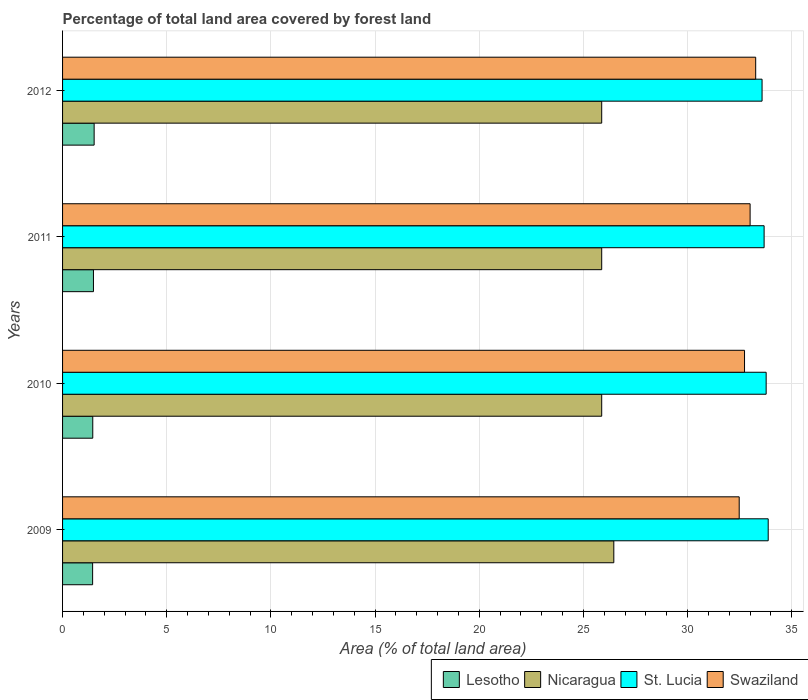Are the number of bars on each tick of the Y-axis equal?
Keep it short and to the point. Yes. How many bars are there on the 4th tick from the top?
Your response must be concise. 4. How many bars are there on the 1st tick from the bottom?
Offer a very short reply. 4. What is the label of the 4th group of bars from the top?
Make the answer very short. 2009. What is the percentage of forest land in Swaziland in 2011?
Make the answer very short. 33. Across all years, what is the maximum percentage of forest land in Nicaragua?
Provide a short and direct response. 26.46. Across all years, what is the minimum percentage of forest land in Nicaragua?
Keep it short and to the point. 25.88. In which year was the percentage of forest land in Lesotho maximum?
Offer a very short reply. 2012. In which year was the percentage of forest land in Lesotho minimum?
Offer a very short reply. 2009. What is the total percentage of forest land in Nicaragua in the graph?
Your answer should be compact. 104.09. What is the difference between the percentage of forest land in St. Lucia in 2011 and that in 2012?
Your response must be concise. 0.1. What is the difference between the percentage of forest land in St. Lucia in 2010 and the percentage of forest land in Nicaragua in 2011?
Provide a succinct answer. 7.89. What is the average percentage of forest land in Swaziland per year?
Give a very brief answer. 32.87. In the year 2012, what is the difference between the percentage of forest land in Lesotho and percentage of forest land in St. Lucia?
Keep it short and to the point. -32.06. What is the ratio of the percentage of forest land in Lesotho in 2010 to that in 2012?
Keep it short and to the point. 0.96. What is the difference between the highest and the second highest percentage of forest land in Nicaragua?
Offer a very short reply. 0.58. What is the difference between the highest and the lowest percentage of forest land in Lesotho?
Your response must be concise. 0.07. Is it the case that in every year, the sum of the percentage of forest land in Swaziland and percentage of forest land in St. Lucia is greater than the sum of percentage of forest land in Lesotho and percentage of forest land in Nicaragua?
Offer a terse response. No. What does the 1st bar from the top in 2011 represents?
Your answer should be compact. Swaziland. What does the 2nd bar from the bottom in 2011 represents?
Offer a very short reply. Nicaragua. Are all the bars in the graph horizontal?
Offer a terse response. Yes. How many years are there in the graph?
Your answer should be compact. 4. What is the difference between two consecutive major ticks on the X-axis?
Provide a short and direct response. 5. How many legend labels are there?
Provide a succinct answer. 4. How are the legend labels stacked?
Your answer should be compact. Horizontal. What is the title of the graph?
Your response must be concise. Percentage of total land area covered by forest land. Does "Libya" appear as one of the legend labels in the graph?
Your answer should be very brief. No. What is the label or title of the X-axis?
Keep it short and to the point. Area (% of total land area). What is the Area (% of total land area) of Lesotho in 2009?
Make the answer very short. 1.44. What is the Area (% of total land area) in Nicaragua in 2009?
Your answer should be very brief. 26.46. What is the Area (% of total land area) of St. Lucia in 2009?
Give a very brief answer. 33.87. What is the Area (% of total land area) of Swaziland in 2009?
Offer a terse response. 32.48. What is the Area (% of total land area) of Lesotho in 2010?
Provide a short and direct response. 1.45. What is the Area (% of total land area) in Nicaragua in 2010?
Provide a succinct answer. 25.88. What is the Area (% of total land area) of St. Lucia in 2010?
Your answer should be compact. 33.77. What is the Area (% of total land area) in Swaziland in 2010?
Your answer should be compact. 32.73. What is the Area (% of total land area) in Lesotho in 2011?
Offer a very short reply. 1.48. What is the Area (% of total land area) in Nicaragua in 2011?
Give a very brief answer. 25.88. What is the Area (% of total land area) in St. Lucia in 2011?
Your answer should be very brief. 33.67. What is the Area (% of total land area) in Swaziland in 2011?
Provide a succinct answer. 33. What is the Area (% of total land area) in Lesotho in 2012?
Make the answer very short. 1.52. What is the Area (% of total land area) of Nicaragua in 2012?
Offer a very short reply. 25.88. What is the Area (% of total land area) of St. Lucia in 2012?
Offer a terse response. 33.57. What is the Area (% of total land area) in Swaziland in 2012?
Your response must be concise. 33.27. Across all years, what is the maximum Area (% of total land area) in Lesotho?
Your answer should be very brief. 1.52. Across all years, what is the maximum Area (% of total land area) of Nicaragua?
Keep it short and to the point. 26.46. Across all years, what is the maximum Area (% of total land area) of St. Lucia?
Offer a terse response. 33.87. Across all years, what is the maximum Area (% of total land area) in Swaziland?
Ensure brevity in your answer.  33.27. Across all years, what is the minimum Area (% of total land area) in Lesotho?
Your response must be concise. 1.44. Across all years, what is the minimum Area (% of total land area) in Nicaragua?
Provide a succinct answer. 25.88. Across all years, what is the minimum Area (% of total land area) of St. Lucia?
Provide a short and direct response. 33.57. Across all years, what is the minimum Area (% of total land area) of Swaziland?
Make the answer very short. 32.48. What is the total Area (% of total land area) of Lesotho in the graph?
Provide a short and direct response. 5.89. What is the total Area (% of total land area) of Nicaragua in the graph?
Provide a short and direct response. 104.09. What is the total Area (% of total land area) in St. Lucia in the graph?
Provide a short and direct response. 134.89. What is the total Area (% of total land area) in Swaziland in the graph?
Keep it short and to the point. 131.48. What is the difference between the Area (% of total land area) of Lesotho in 2009 and that in 2010?
Offer a terse response. -0.01. What is the difference between the Area (% of total land area) of Nicaragua in 2009 and that in 2010?
Your response must be concise. 0.58. What is the difference between the Area (% of total land area) of St. Lucia in 2009 and that in 2010?
Your answer should be compact. 0.1. What is the difference between the Area (% of total land area) in Swaziland in 2009 and that in 2010?
Give a very brief answer. -0.26. What is the difference between the Area (% of total land area) in Lesotho in 2009 and that in 2011?
Make the answer very short. -0.04. What is the difference between the Area (% of total land area) in Nicaragua in 2009 and that in 2011?
Make the answer very short. 0.58. What is the difference between the Area (% of total land area) in St. Lucia in 2009 and that in 2011?
Provide a short and direct response. 0.2. What is the difference between the Area (% of total land area) in Swaziland in 2009 and that in 2011?
Your answer should be very brief. -0.52. What is the difference between the Area (% of total land area) in Lesotho in 2009 and that in 2012?
Offer a terse response. -0.07. What is the difference between the Area (% of total land area) in Nicaragua in 2009 and that in 2012?
Your answer should be compact. 0.58. What is the difference between the Area (% of total land area) of St. Lucia in 2009 and that in 2012?
Make the answer very short. 0.3. What is the difference between the Area (% of total land area) in Swaziland in 2009 and that in 2012?
Offer a very short reply. -0.79. What is the difference between the Area (% of total land area) of Lesotho in 2010 and that in 2011?
Make the answer very short. -0.03. What is the difference between the Area (% of total land area) in St. Lucia in 2010 and that in 2011?
Provide a short and direct response. 0.1. What is the difference between the Area (% of total land area) in Swaziland in 2010 and that in 2011?
Make the answer very short. -0.27. What is the difference between the Area (% of total land area) of Lesotho in 2010 and that in 2012?
Your answer should be very brief. -0.07. What is the difference between the Area (% of total land area) of Nicaragua in 2010 and that in 2012?
Offer a terse response. 0. What is the difference between the Area (% of total land area) of St. Lucia in 2010 and that in 2012?
Offer a terse response. 0.2. What is the difference between the Area (% of total land area) of Swaziland in 2010 and that in 2012?
Provide a succinct answer. -0.53. What is the difference between the Area (% of total land area) of Lesotho in 2011 and that in 2012?
Your answer should be compact. -0.03. What is the difference between the Area (% of total land area) in Nicaragua in 2011 and that in 2012?
Provide a short and direct response. 0. What is the difference between the Area (% of total land area) of St. Lucia in 2011 and that in 2012?
Your answer should be very brief. 0.1. What is the difference between the Area (% of total land area) of Swaziland in 2011 and that in 2012?
Ensure brevity in your answer.  -0.27. What is the difference between the Area (% of total land area) of Lesotho in 2009 and the Area (% of total land area) of Nicaragua in 2010?
Give a very brief answer. -24.43. What is the difference between the Area (% of total land area) in Lesotho in 2009 and the Area (% of total land area) in St. Lucia in 2010?
Provide a short and direct response. -32.33. What is the difference between the Area (% of total land area) of Lesotho in 2009 and the Area (% of total land area) of Swaziland in 2010?
Provide a short and direct response. -31.29. What is the difference between the Area (% of total land area) in Nicaragua in 2009 and the Area (% of total land area) in St. Lucia in 2010?
Offer a very short reply. -7.31. What is the difference between the Area (% of total land area) of Nicaragua in 2009 and the Area (% of total land area) of Swaziland in 2010?
Your response must be concise. -6.27. What is the difference between the Area (% of total land area) of St. Lucia in 2009 and the Area (% of total land area) of Swaziland in 2010?
Ensure brevity in your answer.  1.14. What is the difference between the Area (% of total land area) of Lesotho in 2009 and the Area (% of total land area) of Nicaragua in 2011?
Keep it short and to the point. -24.43. What is the difference between the Area (% of total land area) in Lesotho in 2009 and the Area (% of total land area) in St. Lucia in 2011?
Provide a short and direct response. -32.23. What is the difference between the Area (% of total land area) of Lesotho in 2009 and the Area (% of total land area) of Swaziland in 2011?
Give a very brief answer. -31.56. What is the difference between the Area (% of total land area) of Nicaragua in 2009 and the Area (% of total land area) of St. Lucia in 2011?
Provide a succinct answer. -7.21. What is the difference between the Area (% of total land area) of Nicaragua in 2009 and the Area (% of total land area) of Swaziland in 2011?
Provide a short and direct response. -6.54. What is the difference between the Area (% of total land area) in St. Lucia in 2009 and the Area (% of total land area) in Swaziland in 2011?
Ensure brevity in your answer.  0.87. What is the difference between the Area (% of total land area) of Lesotho in 2009 and the Area (% of total land area) of Nicaragua in 2012?
Provide a succinct answer. -24.43. What is the difference between the Area (% of total land area) of Lesotho in 2009 and the Area (% of total land area) of St. Lucia in 2012?
Give a very brief answer. -32.13. What is the difference between the Area (% of total land area) in Lesotho in 2009 and the Area (% of total land area) in Swaziland in 2012?
Make the answer very short. -31.82. What is the difference between the Area (% of total land area) in Nicaragua in 2009 and the Area (% of total land area) in St. Lucia in 2012?
Offer a very short reply. -7.12. What is the difference between the Area (% of total land area) of Nicaragua in 2009 and the Area (% of total land area) of Swaziland in 2012?
Ensure brevity in your answer.  -6.81. What is the difference between the Area (% of total land area) of St. Lucia in 2009 and the Area (% of total land area) of Swaziland in 2012?
Provide a succinct answer. 0.6. What is the difference between the Area (% of total land area) in Lesotho in 2010 and the Area (% of total land area) in Nicaragua in 2011?
Give a very brief answer. -24.43. What is the difference between the Area (% of total land area) of Lesotho in 2010 and the Area (% of total land area) of St. Lucia in 2011?
Make the answer very short. -32.22. What is the difference between the Area (% of total land area) of Lesotho in 2010 and the Area (% of total land area) of Swaziland in 2011?
Your answer should be compact. -31.55. What is the difference between the Area (% of total land area) in Nicaragua in 2010 and the Area (% of total land area) in St. Lucia in 2011?
Keep it short and to the point. -7.8. What is the difference between the Area (% of total land area) of Nicaragua in 2010 and the Area (% of total land area) of Swaziland in 2011?
Ensure brevity in your answer.  -7.12. What is the difference between the Area (% of total land area) of St. Lucia in 2010 and the Area (% of total land area) of Swaziland in 2011?
Provide a succinct answer. 0.77. What is the difference between the Area (% of total land area) in Lesotho in 2010 and the Area (% of total land area) in Nicaragua in 2012?
Provide a succinct answer. -24.43. What is the difference between the Area (% of total land area) in Lesotho in 2010 and the Area (% of total land area) in St. Lucia in 2012?
Ensure brevity in your answer.  -32.12. What is the difference between the Area (% of total land area) of Lesotho in 2010 and the Area (% of total land area) of Swaziland in 2012?
Offer a terse response. -31.82. What is the difference between the Area (% of total land area) of Nicaragua in 2010 and the Area (% of total land area) of St. Lucia in 2012?
Provide a succinct answer. -7.7. What is the difference between the Area (% of total land area) in Nicaragua in 2010 and the Area (% of total land area) in Swaziland in 2012?
Make the answer very short. -7.39. What is the difference between the Area (% of total land area) of St. Lucia in 2010 and the Area (% of total land area) of Swaziland in 2012?
Your answer should be compact. 0.5. What is the difference between the Area (% of total land area) of Lesotho in 2011 and the Area (% of total land area) of Nicaragua in 2012?
Offer a very short reply. -24.39. What is the difference between the Area (% of total land area) in Lesotho in 2011 and the Area (% of total land area) in St. Lucia in 2012?
Provide a short and direct response. -32.09. What is the difference between the Area (% of total land area) in Lesotho in 2011 and the Area (% of total land area) in Swaziland in 2012?
Keep it short and to the point. -31.79. What is the difference between the Area (% of total land area) in Nicaragua in 2011 and the Area (% of total land area) in St. Lucia in 2012?
Your response must be concise. -7.7. What is the difference between the Area (% of total land area) in Nicaragua in 2011 and the Area (% of total land area) in Swaziland in 2012?
Keep it short and to the point. -7.39. What is the difference between the Area (% of total land area) in St. Lucia in 2011 and the Area (% of total land area) in Swaziland in 2012?
Offer a terse response. 0.4. What is the average Area (% of total land area) in Lesotho per year?
Make the answer very short. 1.47. What is the average Area (% of total land area) of Nicaragua per year?
Provide a succinct answer. 26.02. What is the average Area (% of total land area) in St. Lucia per year?
Your response must be concise. 33.72. What is the average Area (% of total land area) of Swaziland per year?
Keep it short and to the point. 32.87. In the year 2009, what is the difference between the Area (% of total land area) of Lesotho and Area (% of total land area) of Nicaragua?
Ensure brevity in your answer.  -25.02. In the year 2009, what is the difference between the Area (% of total land area) in Lesotho and Area (% of total land area) in St. Lucia?
Your answer should be compact. -32.43. In the year 2009, what is the difference between the Area (% of total land area) in Lesotho and Area (% of total land area) in Swaziland?
Your response must be concise. -31.03. In the year 2009, what is the difference between the Area (% of total land area) of Nicaragua and Area (% of total land area) of St. Lucia?
Give a very brief answer. -7.41. In the year 2009, what is the difference between the Area (% of total land area) of Nicaragua and Area (% of total land area) of Swaziland?
Your answer should be compact. -6.02. In the year 2009, what is the difference between the Area (% of total land area) of St. Lucia and Area (% of total land area) of Swaziland?
Keep it short and to the point. 1.39. In the year 2010, what is the difference between the Area (% of total land area) of Lesotho and Area (% of total land area) of Nicaragua?
Keep it short and to the point. -24.43. In the year 2010, what is the difference between the Area (% of total land area) of Lesotho and Area (% of total land area) of St. Lucia?
Offer a terse response. -32.32. In the year 2010, what is the difference between the Area (% of total land area) in Lesotho and Area (% of total land area) in Swaziland?
Offer a terse response. -31.28. In the year 2010, what is the difference between the Area (% of total land area) of Nicaragua and Area (% of total land area) of St. Lucia?
Ensure brevity in your answer.  -7.89. In the year 2010, what is the difference between the Area (% of total land area) of Nicaragua and Area (% of total land area) of Swaziland?
Your answer should be compact. -6.86. In the year 2010, what is the difference between the Area (% of total land area) in St. Lucia and Area (% of total land area) in Swaziland?
Make the answer very short. 1.04. In the year 2011, what is the difference between the Area (% of total land area) in Lesotho and Area (% of total land area) in Nicaragua?
Provide a succinct answer. -24.39. In the year 2011, what is the difference between the Area (% of total land area) in Lesotho and Area (% of total land area) in St. Lucia?
Offer a very short reply. -32.19. In the year 2011, what is the difference between the Area (% of total land area) in Lesotho and Area (% of total land area) in Swaziland?
Give a very brief answer. -31.52. In the year 2011, what is the difference between the Area (% of total land area) of Nicaragua and Area (% of total land area) of St. Lucia?
Give a very brief answer. -7.8. In the year 2011, what is the difference between the Area (% of total land area) of Nicaragua and Area (% of total land area) of Swaziland?
Your answer should be very brief. -7.12. In the year 2011, what is the difference between the Area (% of total land area) in St. Lucia and Area (% of total land area) in Swaziland?
Your answer should be very brief. 0.67. In the year 2012, what is the difference between the Area (% of total land area) in Lesotho and Area (% of total land area) in Nicaragua?
Give a very brief answer. -24.36. In the year 2012, what is the difference between the Area (% of total land area) in Lesotho and Area (% of total land area) in St. Lucia?
Provide a succinct answer. -32.06. In the year 2012, what is the difference between the Area (% of total land area) in Lesotho and Area (% of total land area) in Swaziland?
Make the answer very short. -31.75. In the year 2012, what is the difference between the Area (% of total land area) of Nicaragua and Area (% of total land area) of St. Lucia?
Provide a succinct answer. -7.7. In the year 2012, what is the difference between the Area (% of total land area) of Nicaragua and Area (% of total land area) of Swaziland?
Ensure brevity in your answer.  -7.39. In the year 2012, what is the difference between the Area (% of total land area) of St. Lucia and Area (% of total land area) of Swaziland?
Keep it short and to the point. 0.31. What is the ratio of the Area (% of total land area) in Nicaragua in 2009 to that in 2010?
Ensure brevity in your answer.  1.02. What is the ratio of the Area (% of total land area) in St. Lucia in 2009 to that in 2010?
Your response must be concise. 1. What is the ratio of the Area (% of total land area) in Swaziland in 2009 to that in 2010?
Your answer should be compact. 0.99. What is the ratio of the Area (% of total land area) in Lesotho in 2009 to that in 2011?
Provide a short and direct response. 0.97. What is the ratio of the Area (% of total land area) in Nicaragua in 2009 to that in 2011?
Your response must be concise. 1.02. What is the ratio of the Area (% of total land area) in St. Lucia in 2009 to that in 2011?
Keep it short and to the point. 1.01. What is the ratio of the Area (% of total land area) of Swaziland in 2009 to that in 2011?
Your answer should be very brief. 0.98. What is the ratio of the Area (% of total land area) in Lesotho in 2009 to that in 2012?
Offer a terse response. 0.95. What is the ratio of the Area (% of total land area) of Nicaragua in 2009 to that in 2012?
Your response must be concise. 1.02. What is the ratio of the Area (% of total land area) of St. Lucia in 2009 to that in 2012?
Provide a succinct answer. 1.01. What is the ratio of the Area (% of total land area) of Swaziland in 2009 to that in 2012?
Your response must be concise. 0.98. What is the ratio of the Area (% of total land area) in Lesotho in 2010 to that in 2011?
Provide a succinct answer. 0.98. What is the ratio of the Area (% of total land area) of Lesotho in 2010 to that in 2012?
Ensure brevity in your answer.  0.96. What is the ratio of the Area (% of total land area) of Nicaragua in 2010 to that in 2012?
Give a very brief answer. 1. What is the ratio of the Area (% of total land area) of St. Lucia in 2010 to that in 2012?
Ensure brevity in your answer.  1.01. What is the ratio of the Area (% of total land area) of Swaziland in 2010 to that in 2012?
Offer a terse response. 0.98. What is the ratio of the Area (% of total land area) of Lesotho in 2011 to that in 2012?
Keep it short and to the point. 0.98. What is the ratio of the Area (% of total land area) of Nicaragua in 2011 to that in 2012?
Provide a succinct answer. 1. What is the ratio of the Area (% of total land area) in St. Lucia in 2011 to that in 2012?
Give a very brief answer. 1. What is the ratio of the Area (% of total land area) of Swaziland in 2011 to that in 2012?
Provide a succinct answer. 0.99. What is the difference between the highest and the second highest Area (% of total land area) in Lesotho?
Offer a very short reply. 0.03. What is the difference between the highest and the second highest Area (% of total land area) of Nicaragua?
Your answer should be compact. 0.58. What is the difference between the highest and the second highest Area (% of total land area) in St. Lucia?
Your response must be concise. 0.1. What is the difference between the highest and the second highest Area (% of total land area) of Swaziland?
Keep it short and to the point. 0.27. What is the difference between the highest and the lowest Area (% of total land area) of Lesotho?
Your answer should be compact. 0.07. What is the difference between the highest and the lowest Area (% of total land area) of Nicaragua?
Make the answer very short. 0.58. What is the difference between the highest and the lowest Area (% of total land area) of St. Lucia?
Provide a short and direct response. 0.3. What is the difference between the highest and the lowest Area (% of total land area) of Swaziland?
Keep it short and to the point. 0.79. 